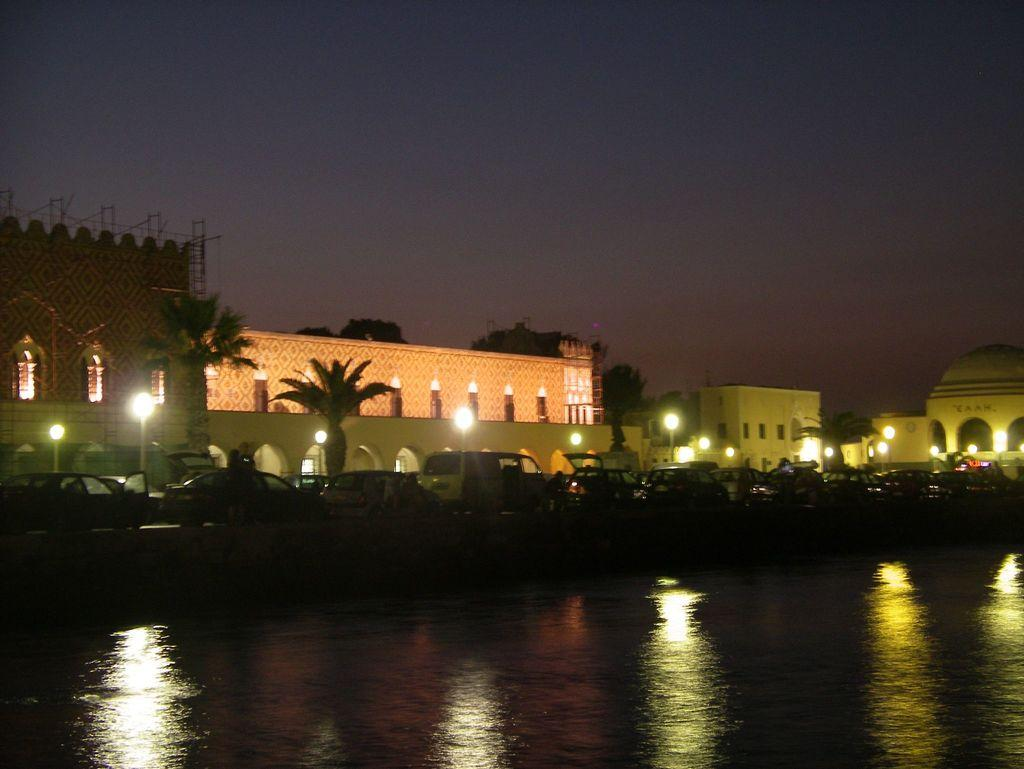What is the main feature of the image? There is water in the image. What else can be seen in the image besides the water? There are vehicles on the road, light poles, trees with green color, a building with a white color, and the sky in blue color. Can you describe the vehicles in the image? The vehicles are on the road, but their specific types are not mentioned in the facts. What is the color of the sky in the image? The sky is in blue color in the image. What type of sweater is your aunt wearing in the image? There is no mention of an aunt or a sweater in the image or the provided facts. 